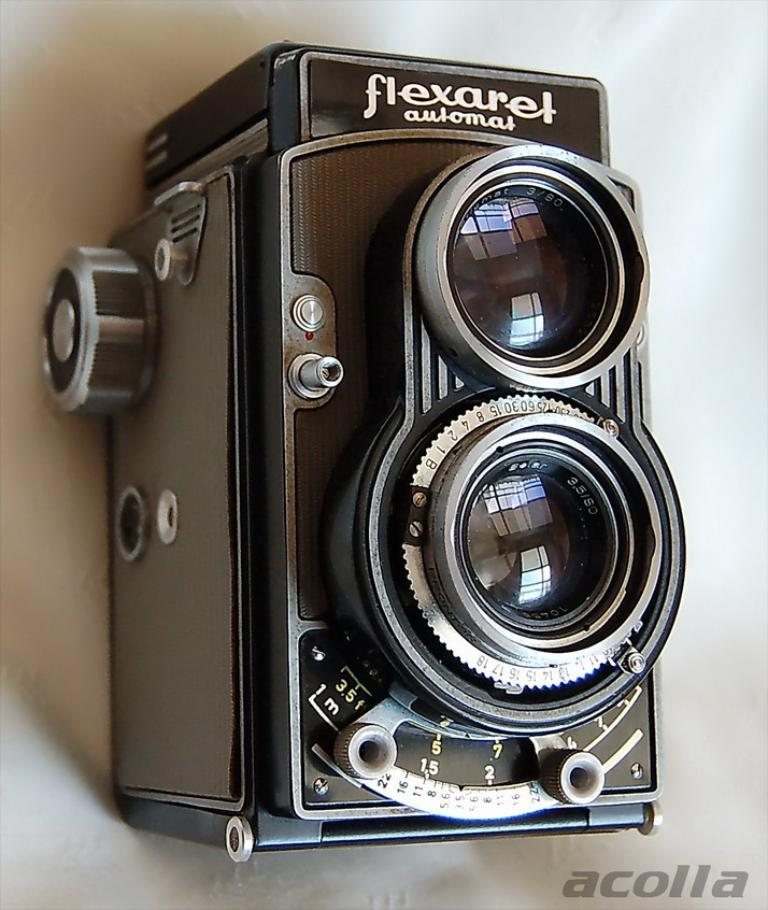What object is the main subject of the image? There is a camera in the image. Are there any markings or labels on the camera? Yes, there is written text on the camera. Is there any text visible elsewhere in the image? Yes, there is written text at the bottom of the image. How many bears can be seen playing in the sand in the image? There are no bears or sand present in the image; it features a camera with written text and additional text at the bottom. 